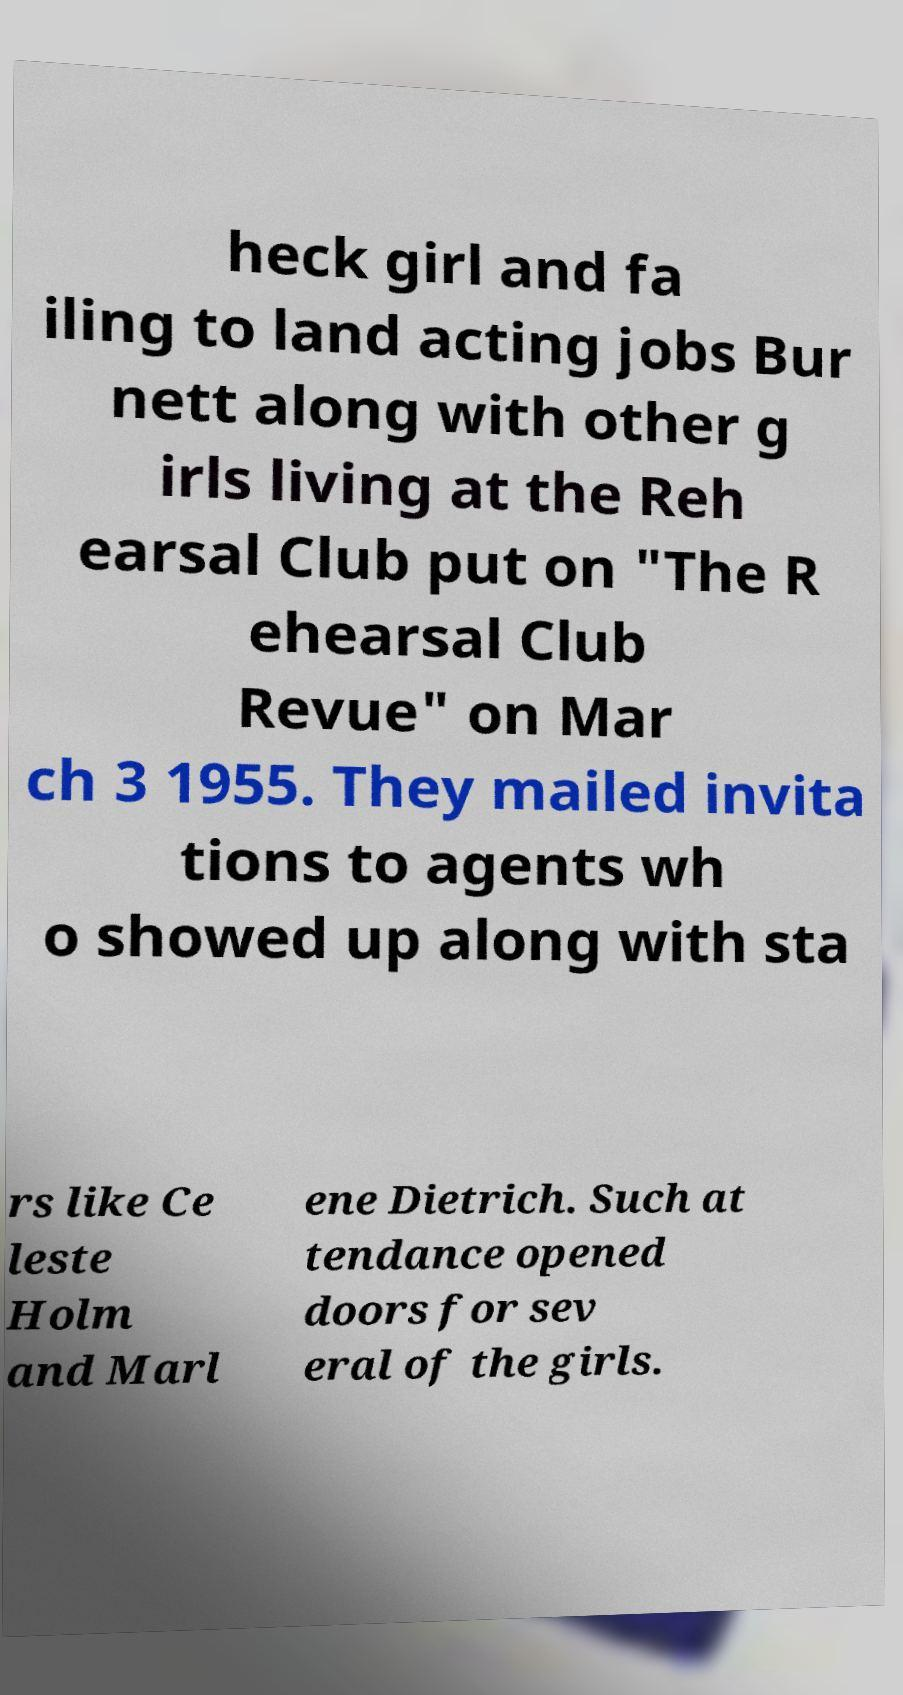There's text embedded in this image that I need extracted. Can you transcribe it verbatim? heck girl and fa iling to land acting jobs Bur nett along with other g irls living at the Reh earsal Club put on "The R ehearsal Club Revue" on Mar ch 3 1955. They mailed invita tions to agents wh o showed up along with sta rs like Ce leste Holm and Marl ene Dietrich. Such at tendance opened doors for sev eral of the girls. 